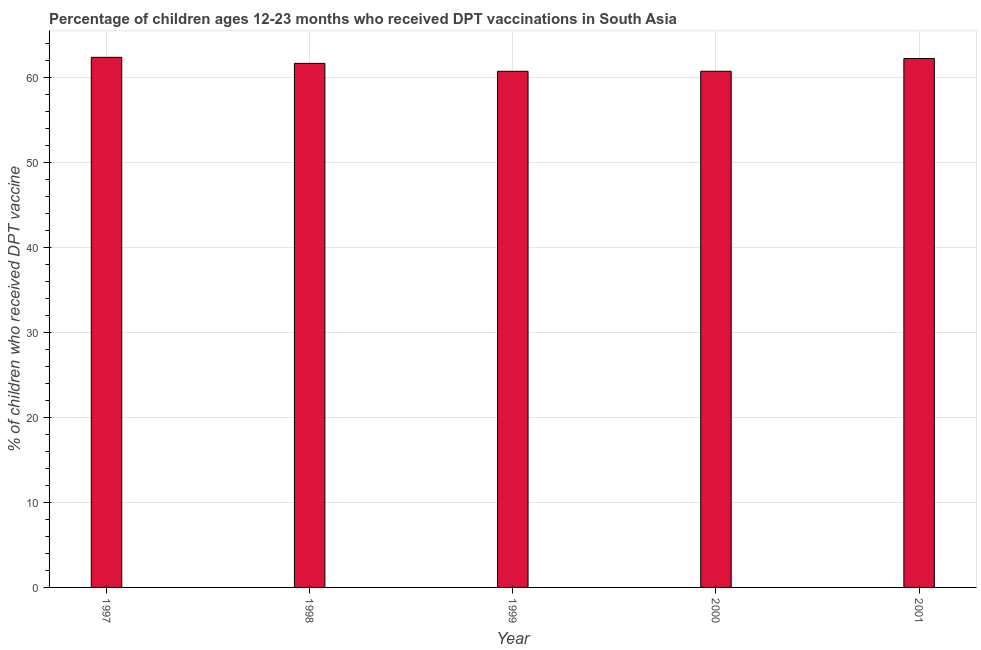Does the graph contain any zero values?
Provide a short and direct response. No. Does the graph contain grids?
Give a very brief answer. Yes. What is the title of the graph?
Give a very brief answer. Percentage of children ages 12-23 months who received DPT vaccinations in South Asia. What is the label or title of the Y-axis?
Provide a succinct answer. % of children who received DPT vaccine. What is the percentage of children who received dpt vaccine in 1999?
Make the answer very short. 60.7. Across all years, what is the maximum percentage of children who received dpt vaccine?
Your answer should be compact. 62.35. Across all years, what is the minimum percentage of children who received dpt vaccine?
Make the answer very short. 60.7. In which year was the percentage of children who received dpt vaccine maximum?
Your answer should be compact. 1997. What is the sum of the percentage of children who received dpt vaccine?
Your response must be concise. 307.6. What is the difference between the percentage of children who received dpt vaccine in 2000 and 2001?
Make the answer very short. -1.5. What is the average percentage of children who received dpt vaccine per year?
Your answer should be very brief. 61.52. What is the median percentage of children who received dpt vaccine?
Provide a succinct answer. 61.64. In how many years, is the percentage of children who received dpt vaccine greater than 20 %?
Ensure brevity in your answer.  5. What is the ratio of the percentage of children who received dpt vaccine in 1997 to that in 2001?
Offer a very short reply. 1. Is the percentage of children who received dpt vaccine in 1999 less than that in 2000?
Provide a short and direct response. Yes. Is the difference between the percentage of children who received dpt vaccine in 1999 and 2000 greater than the difference between any two years?
Provide a short and direct response. No. What is the difference between the highest and the second highest percentage of children who received dpt vaccine?
Make the answer very short. 0.14. Is the sum of the percentage of children who received dpt vaccine in 1998 and 2001 greater than the maximum percentage of children who received dpt vaccine across all years?
Offer a terse response. Yes. What is the difference between the highest and the lowest percentage of children who received dpt vaccine?
Your response must be concise. 1.64. In how many years, is the percentage of children who received dpt vaccine greater than the average percentage of children who received dpt vaccine taken over all years?
Your answer should be compact. 3. How many bars are there?
Provide a succinct answer. 5. Are the values on the major ticks of Y-axis written in scientific E-notation?
Provide a short and direct response. No. What is the % of children who received DPT vaccine of 1997?
Provide a succinct answer. 62.35. What is the % of children who received DPT vaccine in 1998?
Give a very brief answer. 61.64. What is the % of children who received DPT vaccine of 1999?
Make the answer very short. 60.7. What is the % of children who received DPT vaccine of 2000?
Offer a terse response. 60.71. What is the % of children who received DPT vaccine in 2001?
Ensure brevity in your answer.  62.21. What is the difference between the % of children who received DPT vaccine in 1997 and 1998?
Make the answer very short. 0.71. What is the difference between the % of children who received DPT vaccine in 1997 and 1999?
Provide a short and direct response. 1.64. What is the difference between the % of children who received DPT vaccine in 1997 and 2000?
Keep it short and to the point. 1.64. What is the difference between the % of children who received DPT vaccine in 1997 and 2001?
Provide a succinct answer. 0.14. What is the difference between the % of children who received DPT vaccine in 1998 and 1999?
Your answer should be very brief. 0.93. What is the difference between the % of children who received DPT vaccine in 1998 and 2000?
Offer a terse response. 0.93. What is the difference between the % of children who received DPT vaccine in 1998 and 2001?
Keep it short and to the point. -0.57. What is the difference between the % of children who received DPT vaccine in 1999 and 2000?
Your response must be concise. -0.01. What is the difference between the % of children who received DPT vaccine in 1999 and 2001?
Your answer should be very brief. -1.5. What is the difference between the % of children who received DPT vaccine in 2000 and 2001?
Your answer should be very brief. -1.5. What is the ratio of the % of children who received DPT vaccine in 1998 to that in 1999?
Your response must be concise. 1.01. What is the ratio of the % of children who received DPT vaccine in 1998 to that in 2000?
Offer a terse response. 1.01. What is the ratio of the % of children who received DPT vaccine in 1998 to that in 2001?
Provide a succinct answer. 0.99. What is the ratio of the % of children who received DPT vaccine in 1999 to that in 2000?
Provide a short and direct response. 1. 